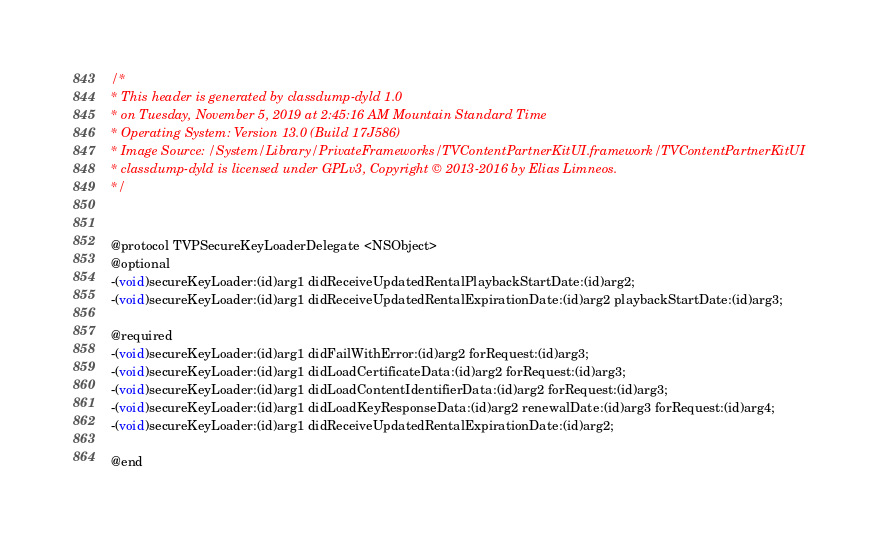Convert code to text. <code><loc_0><loc_0><loc_500><loc_500><_C_>/*
* This header is generated by classdump-dyld 1.0
* on Tuesday, November 5, 2019 at 2:45:16 AM Mountain Standard Time
* Operating System: Version 13.0 (Build 17J586)
* Image Source: /System/Library/PrivateFrameworks/TVContentPartnerKitUI.framework/TVContentPartnerKitUI
* classdump-dyld is licensed under GPLv3, Copyright © 2013-2016 by Elias Limneos.
*/


@protocol TVPSecureKeyLoaderDelegate <NSObject>
@optional
-(void)secureKeyLoader:(id)arg1 didReceiveUpdatedRentalPlaybackStartDate:(id)arg2;
-(void)secureKeyLoader:(id)arg1 didReceiveUpdatedRentalExpirationDate:(id)arg2 playbackStartDate:(id)arg3;

@required
-(void)secureKeyLoader:(id)arg1 didFailWithError:(id)arg2 forRequest:(id)arg3;
-(void)secureKeyLoader:(id)arg1 didLoadCertificateData:(id)arg2 forRequest:(id)arg3;
-(void)secureKeyLoader:(id)arg1 didLoadContentIdentifierData:(id)arg2 forRequest:(id)arg3;
-(void)secureKeyLoader:(id)arg1 didLoadKeyResponseData:(id)arg2 renewalDate:(id)arg3 forRequest:(id)arg4;
-(void)secureKeyLoader:(id)arg1 didReceiveUpdatedRentalExpirationDate:(id)arg2;

@end

</code> 